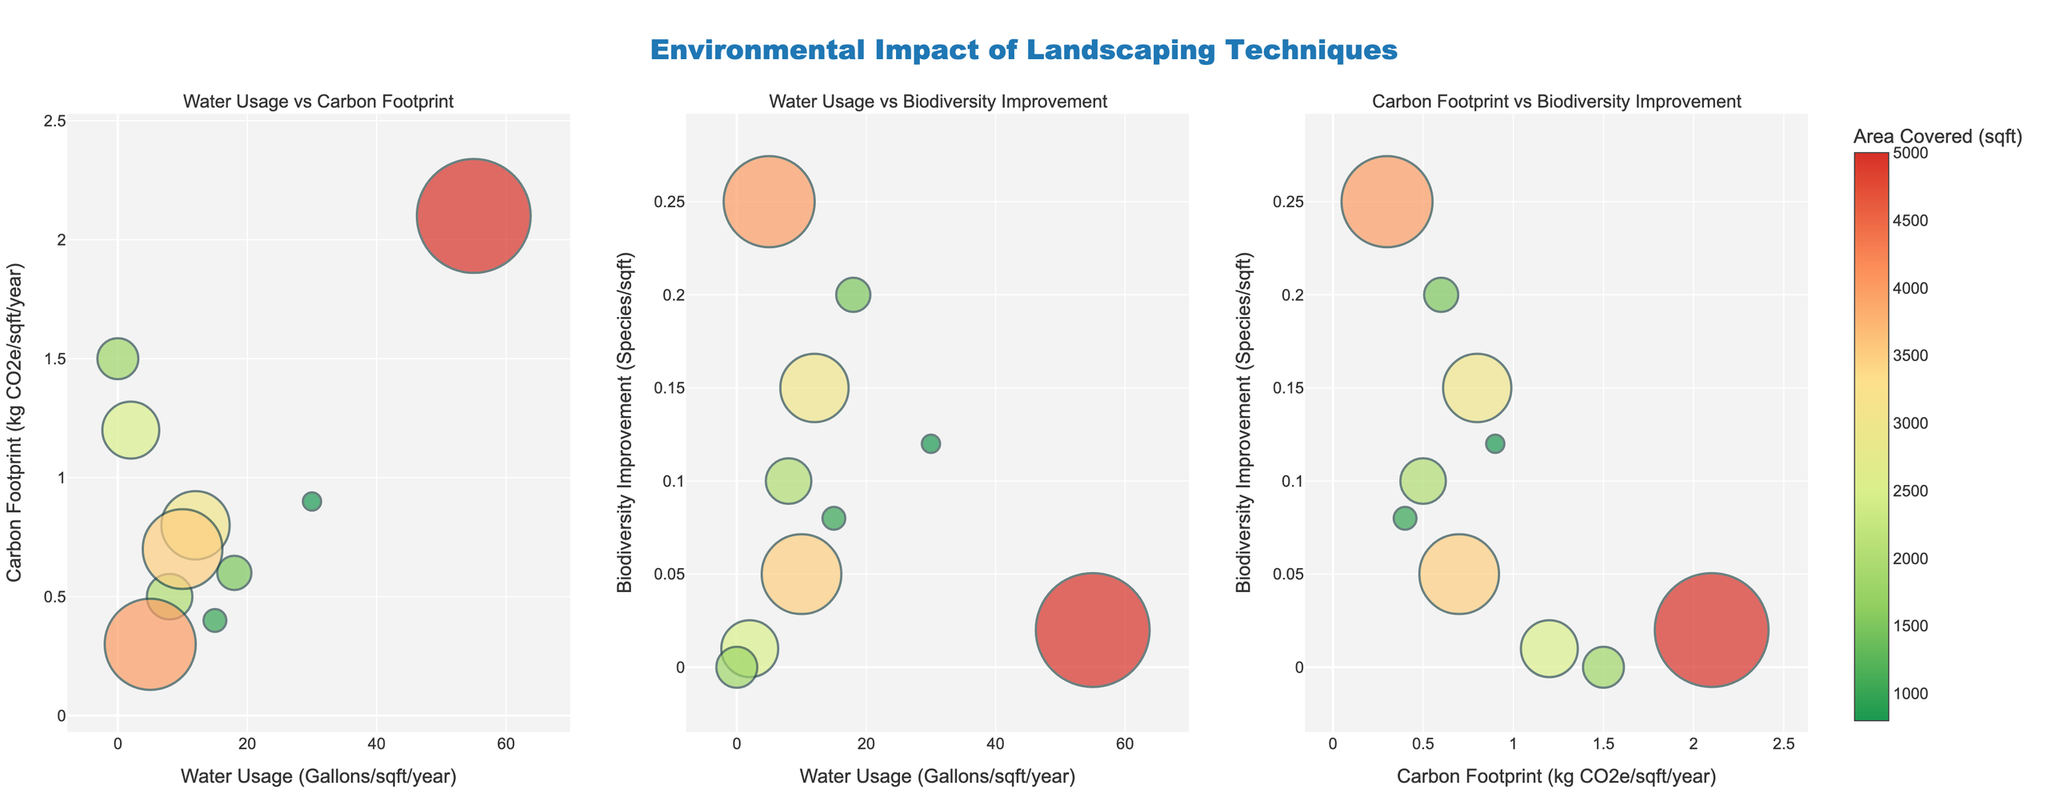What's the title of the figure? The title is typically displayed prominently at the top of the figure. Observing the layout, it is clear the title is "Environmental Impact of Landscaping Techniques".
Answer: Environmental Impact of Landscaping Techniques Which landscaping technique has the lowest water usage? By looking at the x-axis on the "Water Usage vs Carbon Footprint" or "Water Usage vs Biodiversity Improvement" subplots, identify the technique with the lowest x-axis value. In this case, it's "Synthetic Turf" with 0 gallons/sqft/year.
Answer: Synthetic Turf What's the relationship between water usage and carbon footprint for Traditional Lawn? Locate the bubble for "Traditional Lawn" in the "Water Usage vs Carbon Footprint" subplot. The water usage is 55 gallons/sqft/year (x-axis), and the carbon footprint is 2.1 kg CO2e/sqft/year (y-axis).
Answer: 55 gallons/sqft/year and 2.1 kg CO2e/sqft/year Which technique improves biodiversity the most? In the subplots involving biodiversity improvement on the y-axis ("Water Usage vs Biodiversity Improvement" and "Carbon Footprint vs Biodiversity Improvement"), find the bubbl with the highest y-axis value. It is "Wildflower Meadow" with 0.25 species/sqft.
Answer: Wildflower Meadow Compare the carbon footprint of Permeable Pavement and Green Roof techniques. Which one is higher? Locate the data points for "Permeable Pavement" and "Green Roof" in the "Water Usage vs Carbon Footprint" or "Carbon Footprint vs Biodiversity Improvement" subplots. "Permeable Pavement" has 1.2 kg CO2e/sqft/year, higher than "Green Roof" with 0.4 kg CO2e/sqft/year.
Answer: Permeable Pavement Which technique covers the largest area? The size of the bubbles indicates the area covered. The bubble with the largest size represents the "Traditional Lawn" with 5000 sqft.
Answer: Traditional Lawn What's the median water usage across all techniques? List water usage values from the smallest to largest: 0, 2, 5, 8, 10, 12, 15, 18, 30, 55. The middle values (10 + 12)/2 = 11 gallons/sqft/year.
Answer: 11 gallons/sqft/year Is there any technique with high biodiversity improvement but low water usage? Examine the "Water Usage vs Biodiversity Improvement" subplot to find techniques in the upper-left quadrant. "Wildflower Meadow" with 0.25 species/sqft and 5 gallons/sqft/year fits this criterion.
Answer: Wildflower Meadow Which technique has a moderate water usage but very low biodiversity improvement? Identify a bubble in the middle of the x-axis and lower part of the y-axis in the "Water Usage vs Biodiversity Improvement" subplot. "Mulch Landscaping" has 10 gallons/sqft/year (moderate water usage) and 0.05 species/sqft (low biodiversity).
Answer: Mulch Landscaping 